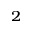<formula> <loc_0><loc_0><loc_500><loc_500>_ { 2 }</formula> 